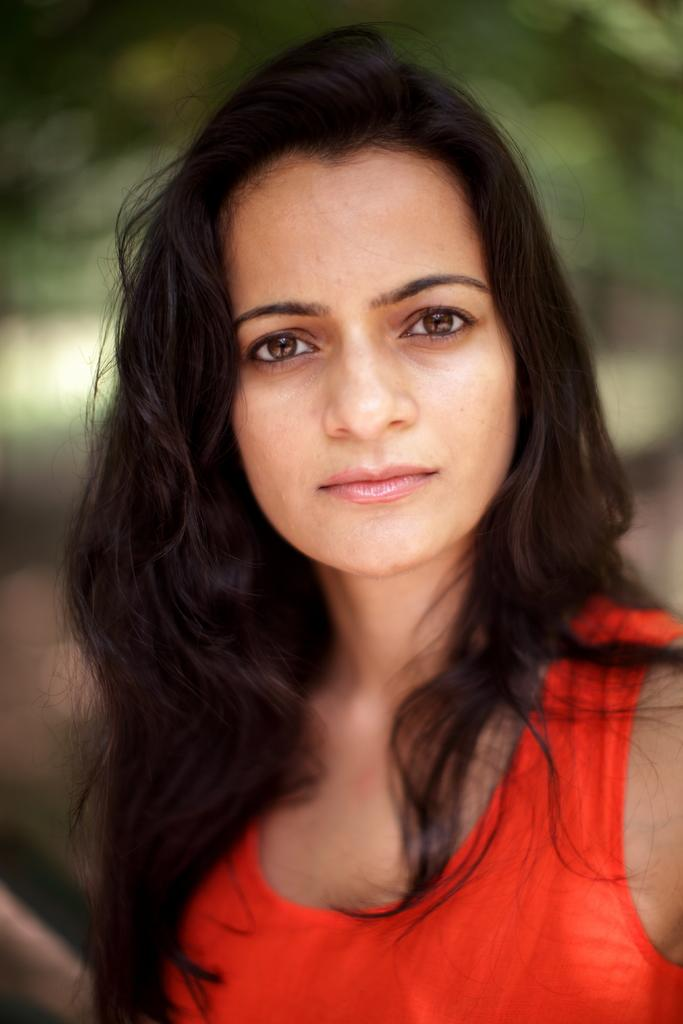What is the main subject of the image? The main subject of the image is a woman. What is the woman wearing in the image? The woman is wearing a red top. What can be seen in the background of the image? There are plants in the background of the image. What type of nail is the woman using in the image? There is no nail visible in the image, and therefore no such activity can be observed. What type of order is the woman following in the image? There is no indication in the image that the woman is following any specific order. 